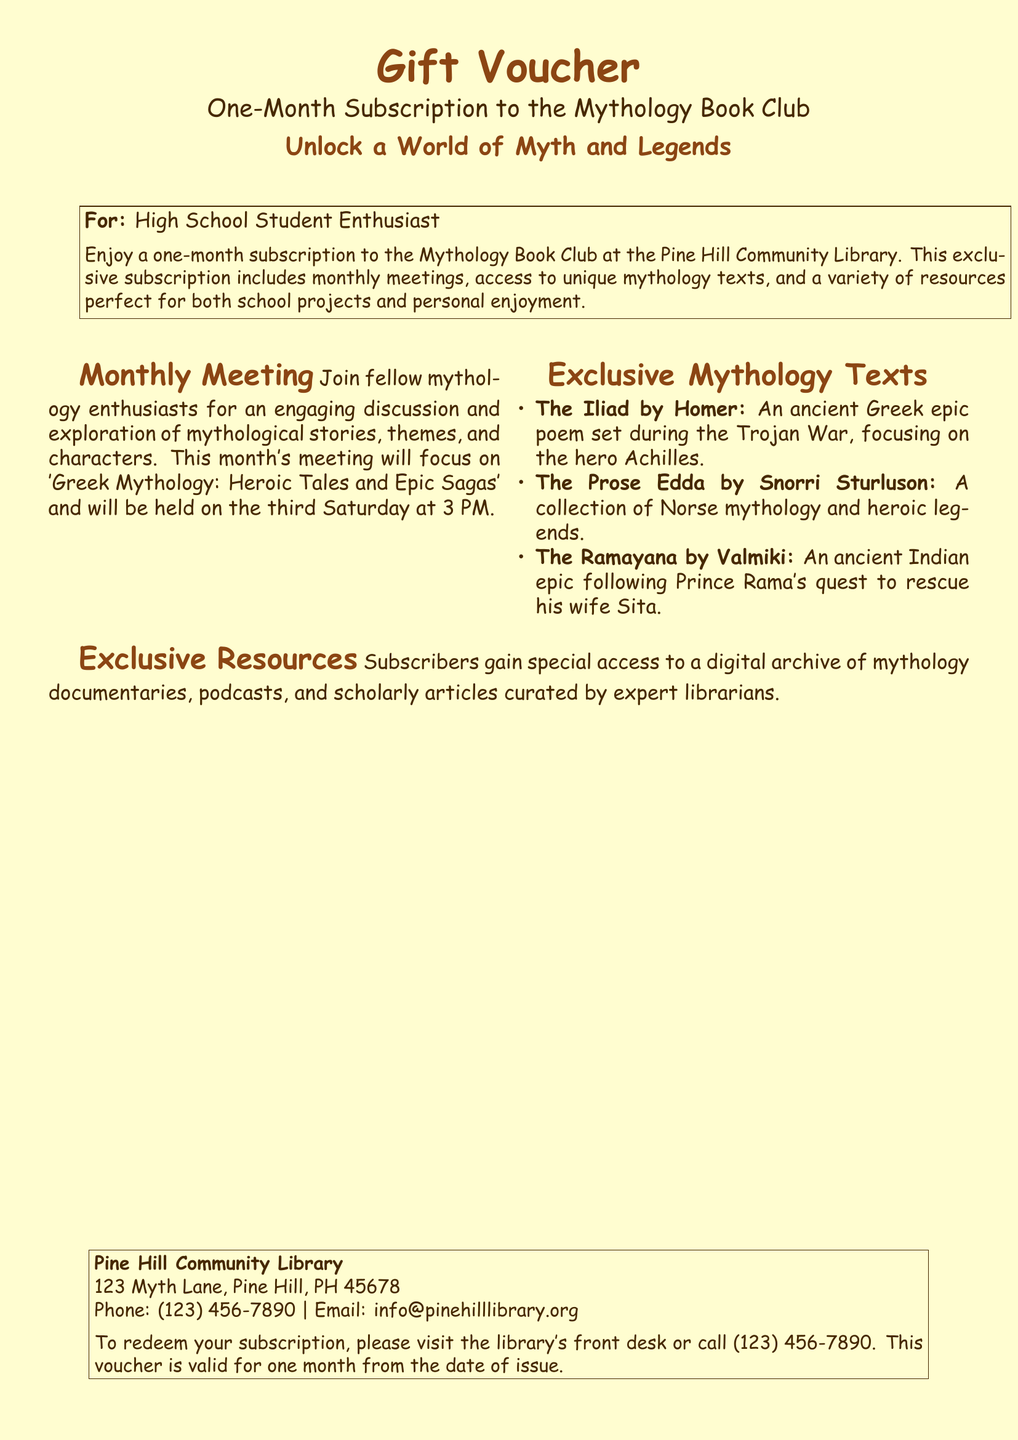What is the gift voucher for? The gift voucher is for a one-month subscription to the Mythology Book Club at the Pine Hill Community Library.
Answer: One-month subscription to the Mythology Book Club When is the monthly meeting? The monthly meeting is scheduled for the third Saturday at 3 PM.
Answer: Third Saturday at 3 PM What theme will the meeting focus on? The meeting will focus on 'Greek Mythology: Heroic Tales and Epic Sagas'.
Answer: Greek Mythology: Heroic Tales and Epic Sagas What is one of the exclusive texts mentioned? The exclusive texts include 'The Iliad by Homer'.
Answer: The Iliad by Homer Where is the Pine Hill Community Library located? The library is located at 123 Myth Lane, Pine Hill, PH 45678.
Answer: 123 Myth Lane, Pine Hill, PH 45678 What type of access do subscribers gain? Subscribers gain special access to a digital archive of mythology documentaries, podcasts, and scholarly articles.
Answer: Digital archive of mythology documentaries, podcasts, and scholarly articles How do you redeem the subscription? The subscription can be redeemed by visiting the library's front desk or calling the library.
Answer: Front desk or call (123) 456-7890 What is the phone number for the library? The phone number for the library is (123) 456-7890.
Answer: (123) 456-7890 